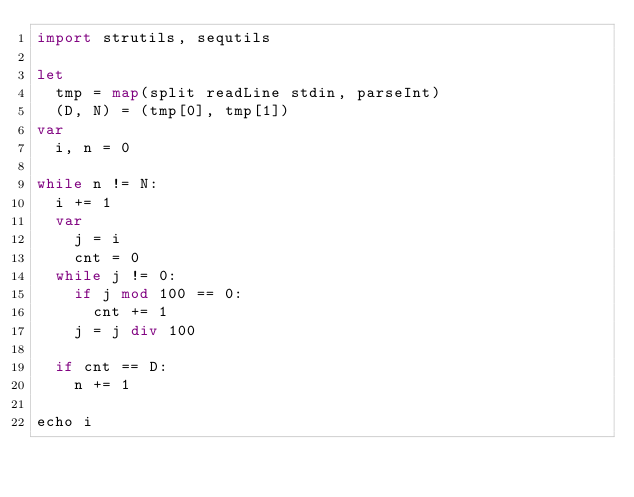Convert code to text. <code><loc_0><loc_0><loc_500><loc_500><_Nim_>import strutils, sequtils

let
  tmp = map(split readLine stdin, parseInt)
  (D, N) = (tmp[0], tmp[1])
var
  i, n = 0

while n != N:
  i += 1
  var
    j = i
    cnt = 0
  while j != 0:
    if j mod 100 == 0:
      cnt += 1
    j = j div 100

  if cnt == D:
    n += 1

echo i
</code> 